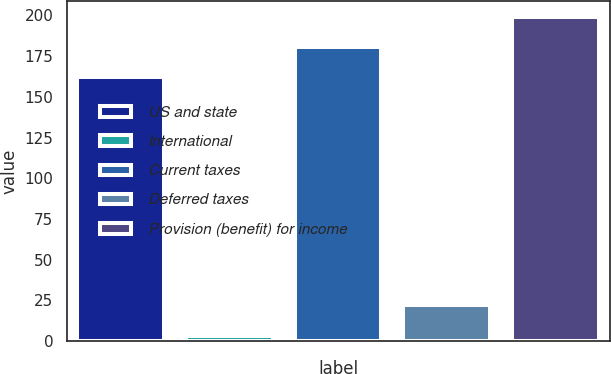Convert chart to OTSL. <chart><loc_0><loc_0><loc_500><loc_500><bar_chart><fcel>US and state<fcel>International<fcel>Current taxes<fcel>Deferred taxes<fcel>Provision (benefit) for income<nl><fcel>162<fcel>3<fcel>180.4<fcel>22<fcel>198.8<nl></chart> 